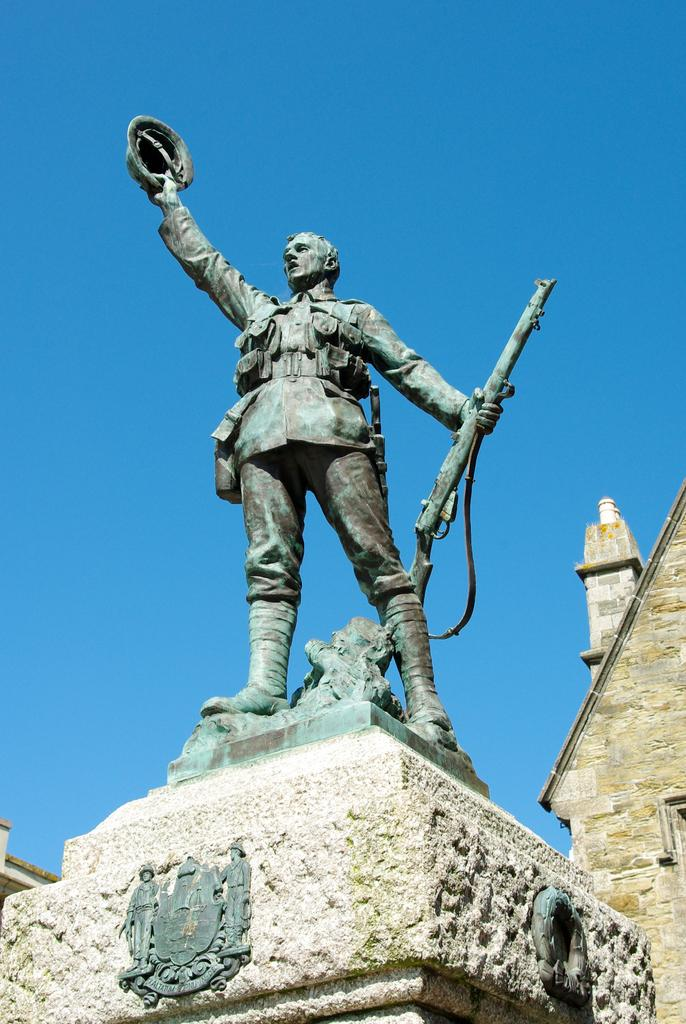What is the main subject in the image? There is a statue in the image. What can be seen behind the statue? There is a building visible on the backside of the statue. What is visible in the sky in the image? The sky is visible in the image. How would you describe the weather based on the appearance of the sky? The sky appears to be cloudy in the image. What type of cactus can be seen growing on the statue in the image? There is no cactus present on the statue in the image. What religious belief does the statue represent in the image? The provided facts do not mention any religious beliefs associated with the statue, so it cannot be determined from the image. 